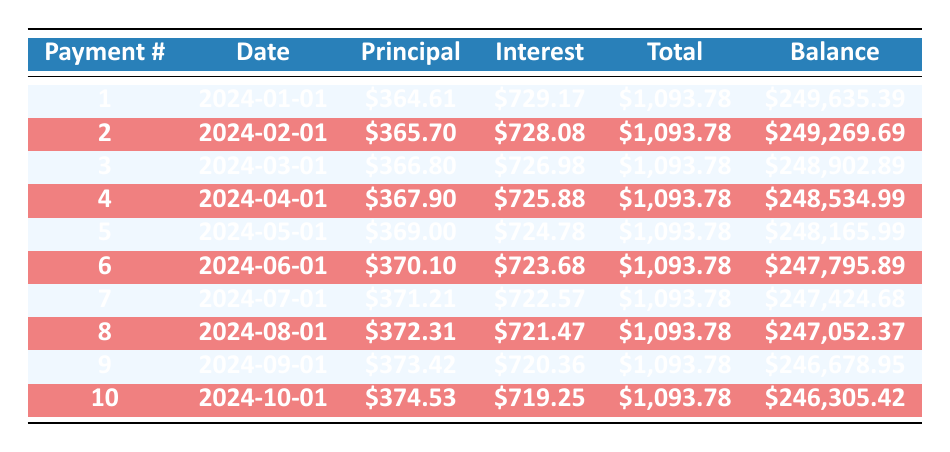What is the total payment for the first month? The table shows that the total payment for the first payment (payment number 1) is listed as $1,093.78 in the total payment column.
Answer: 1093.78 How much principal is paid off in the second payment? The second payment (payment number 2) lists the principal payment as $365.70 in the principal payment column.
Answer: 365.70 Is the interest payment for the first payment greater than the interest payment for the second payment? The interest payment for the first payment is $729.17, while the interest payment for the second payment is $728.08. Since $729.17 is greater than $728.08, the answer is yes.
Answer: Yes What is the remaining balance after the fourth payment? After the fourth payment (payment number 4), the remaining balance is noted as $248,534.99 in the remaining balance column.
Answer: 248534.99 What is the total principal paid over the first three payments? The principal payments for the first three payments are $364.61, $365.70, and $366.80, respectively. Adding these amounts gives us $364.61 + $365.70 + $366.80 = $1,097.11.
Answer: 1097.11 Is the total payment consistent across all payments in the table? The total payment amounts for all listed payments in the table are the same at $1,093.78, indicating that the total payment is consistent.
Answer: Yes What is the change in remaining balance from the first to the third payment? The remaining balance after the first payment is $249,635.39 and after the third payment is $248,902.89. The change is calculated as $249,635.39 - $248,902.89 = $732.50.
Answer: 732.50 How much interest is paid in the sixth payment? The sixth payment (payment number 6) shows the interest payment as $723.68 in the interest payment column.
Answer: 723.68 What is the average principal paid for the first ten payments? The principal payments for the first ten payments can be added: ($364.61 + $365.70 + $366.80 + $367.90 + $369.00 + $370.10 + $371.21 + $372.31 + $373.42 + $374.53) = $3,699.18. Dividing by 10 gives an average of $369.92.
Answer: 369.92 What is the total interest paid in the first five payments? The interest payments for the first five payments are $729.17, $728.08, $726.98, $725.88, and $724.78. Adding these amounts gives $729.17 + $728.08 + $726.98 + $725.88 + $724.78 = $3,634.89.
Answer: 3634.89 